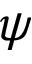Convert formula to latex. <formula><loc_0><loc_0><loc_500><loc_500>\psi</formula> 